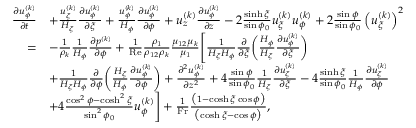Convert formula to latex. <formula><loc_0><loc_0><loc_500><loc_500>\begin{array} { r } { \begin{array} { r l } { \frac { \partial u _ { \phi } ^ { ( k ) } } { \partial t } } & { + \frac { u _ { \xi } ^ { ( k ) } } { H _ { \xi } } \frac { \partial u _ { \phi } ^ { ( k ) } } { \partial \xi } + \frac { u _ { \phi } ^ { ( k ) } } { H _ { \phi } } \frac { \partial u _ { \phi } ^ { ( k ) } } { \partial \phi } + u _ { z } ^ { ( k ) } \frac { \partial u _ { \phi } ^ { ( k ) } } { \partial z } - 2 \frac { \sinh \xi } { \sin \phi _ { 0 } } u _ { \xi } ^ { ( k ) } u _ { \phi } ^ { ( k ) } + 2 \frac { \sin \phi } { \sin \phi _ { 0 } } \left ( u _ { \xi } ^ { ( k ) } \right ) ^ { 2 } } \\ { = } & { - \frac { 1 } { \rho _ { k } } \frac { 1 } { H _ { \phi } } \frac { \partial p ^ { ( k ) } } { \partial \phi } + \frac { 1 } { R e } \frac { \rho _ { 1 } } { \rho _ { 1 2 } \rho _ { k } } \frac { \mu _ { 1 2 } \mu _ { k } } { \mu _ { 1 } } \left [ \frac { 1 } { H _ { \xi } H _ { \phi } } \frac { \partial } { \partial \xi } \left ( \frac { H _ { \phi } } { H _ { \xi } } \frac { \partial u _ { \phi } ^ { ( k ) } } { \partial \xi } \right ) } \\ & { + \frac { 1 } { H _ { \xi } H _ { \phi } } \frac { \partial } { \partial \phi } \left ( \frac { H _ { \xi } } { H _ { \phi } } \frac { \partial u _ { \phi } ^ { ( k ) } } { \partial \phi } \right ) + \frac { \partial ^ { 2 } u _ { \phi } ^ { ( k ) } } { \partial z ^ { 2 } } + 4 \frac { \sin \phi } { \sin \phi _ { 0 } } \frac { 1 } { H _ { \xi } } \frac { \partial u _ { \xi } ^ { ( k ) } } { \partial \xi } - 4 \frac { \sinh \xi } { \sin \phi _ { 0 } } \frac { 1 } { H _ { \phi } } \frac { \partial u _ { \xi } ^ { ( k ) } } { \partial \phi } } \\ & { + 4 \frac { \cos ^ { 2 } \phi - \cosh ^ { 2 } \xi } { \sin ^ { 2 } \phi _ { 0 } } u _ { \phi } ^ { ( k ) } \right ] + \frac { 1 } { F r } \frac { \left ( 1 - \cosh \xi \cos \phi \right ) } { \left ( \cosh \xi - \cos \phi \right ) } , } \end{array} } \end{array}</formula> 